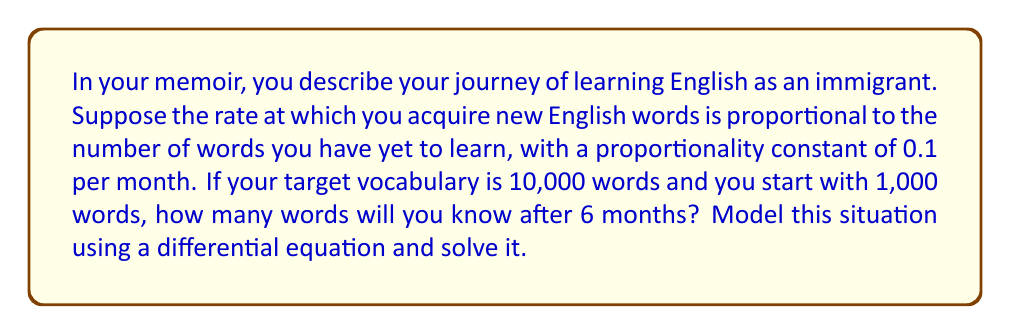Solve this math problem. Let's approach this step-by-step:

1) Let $W(t)$ be the number of words known at time $t$ (in months).

2) The rate of change of $W$ with respect to $t$ is proportional to the number of words yet to learn:

   $$\frac{dW}{dt} = 0.1(10000 - W)$$

3) This is a first-order linear differential equation. We can solve it as follows:

   $$\frac{dW}{10000 - W} = 0.1dt$$

4) Integrating both sides:

   $$-\ln(10000 - W) = 0.1t + C$$

5) Using the initial condition $W(0) = 1000$:

   $$-\ln(9000) = C$$

6) Therefore, the general solution is:

   $$-\ln(10000 - W) = 0.1t - \ln(9000)$$

7) Simplifying:

   $$10000 - W = 9000e^{-0.1t}$$
   $$W = 10000 - 9000e^{-0.1t}$$

8) To find $W(6)$, we substitute $t = 6$:

   $$W(6) = 10000 - 9000e^{-0.6}$$

9) Calculating this:

   $$W(6) \approx 5488.12$$

10) Rounding to the nearest whole number (as we're dealing with words):

    $$W(6) \approx 5488 \text{ words}$$
Answer: 5488 words 